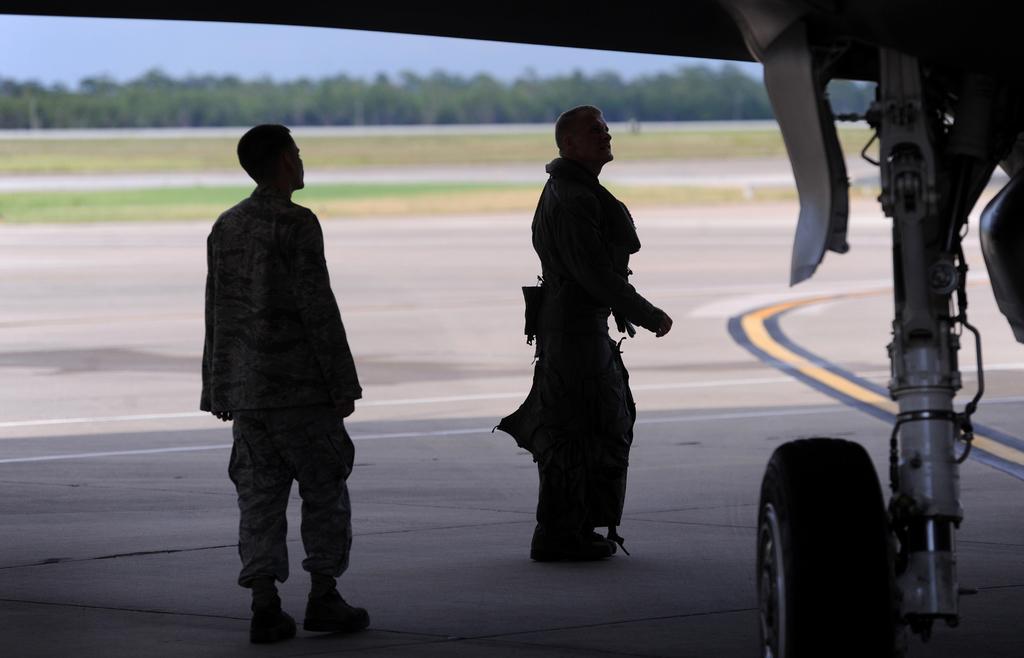Describe this image in one or two sentences. In this image in the center there are two persons who are standing and on the right side there is an airplane, in the background there are some trees and grass. At the bottom there is a walkway. 